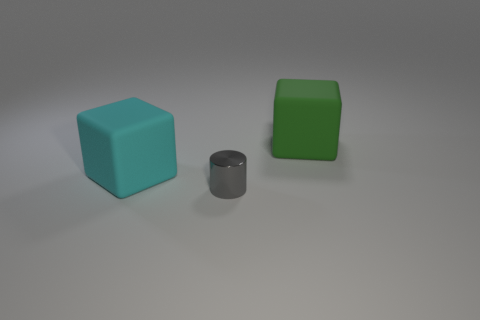Add 1 matte blocks. How many objects exist? 4 Subtract all cubes. How many objects are left? 1 Subtract 0 purple cylinders. How many objects are left? 3 Subtract all gray shiny cylinders. Subtract all tiny gray shiny things. How many objects are left? 1 Add 2 tiny cylinders. How many tiny cylinders are left? 3 Add 3 tiny matte balls. How many tiny matte balls exist? 3 